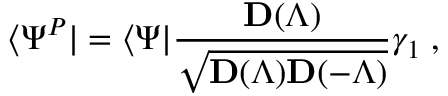Convert formula to latex. <formula><loc_0><loc_0><loc_500><loc_500>\langle \Psi ^ { P } | = \langle \Psi | \frac { { \mathbf D } ( \Lambda ) } { \sqrt { { \mathbf D } ( \Lambda ) { \mathbf D } ( - \Lambda ) } } \gamma _ { 1 } \, ,</formula> 